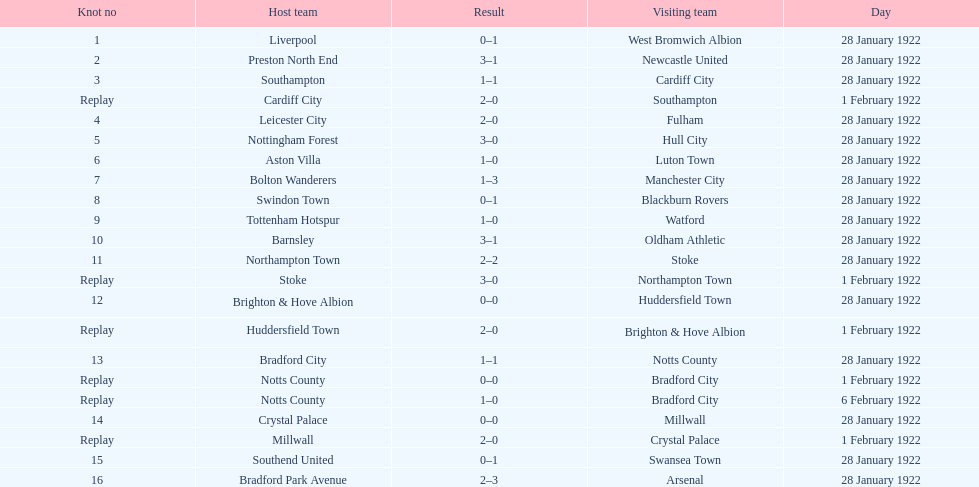How many total points were scored in the second round proper? 45. 